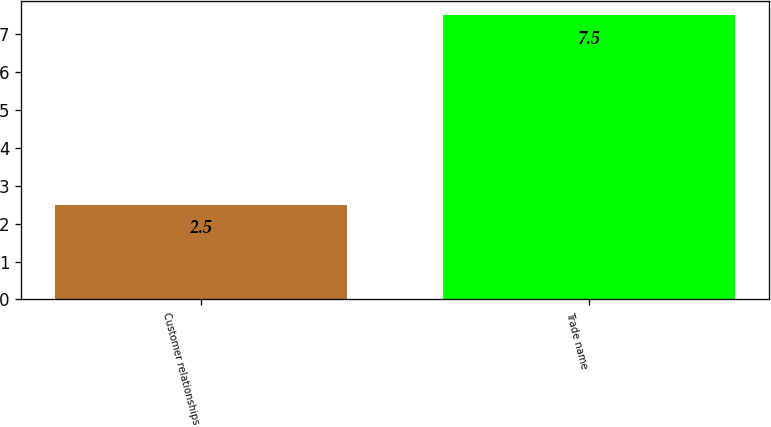Convert chart to OTSL. <chart><loc_0><loc_0><loc_500><loc_500><bar_chart><fcel>Customer relationships<fcel>Trade name<nl><fcel>2.5<fcel>7.5<nl></chart> 